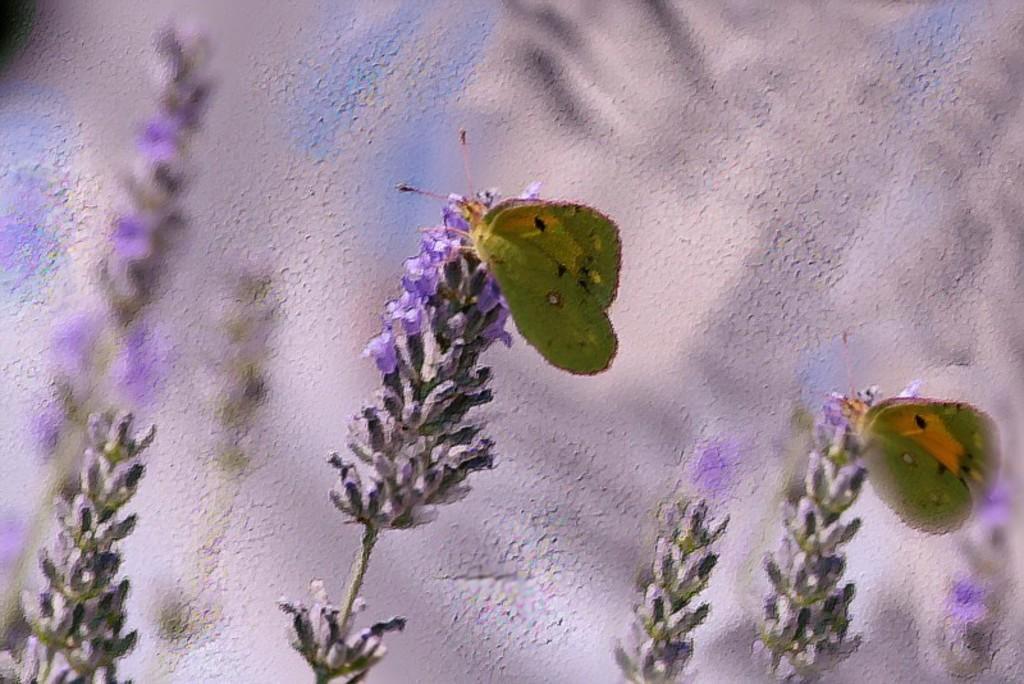How would you summarize this image in a sentence or two? In this picture, it is looking like a painting of two insects on the flowers. Behind the flowers there is a wall. 